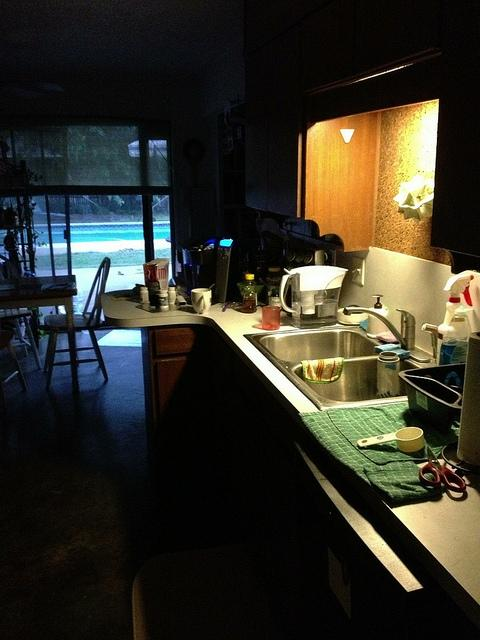What is to the right of the sink?

Choices:
A) cat
B) cardboard box
C) scissors
D) roach scissors 